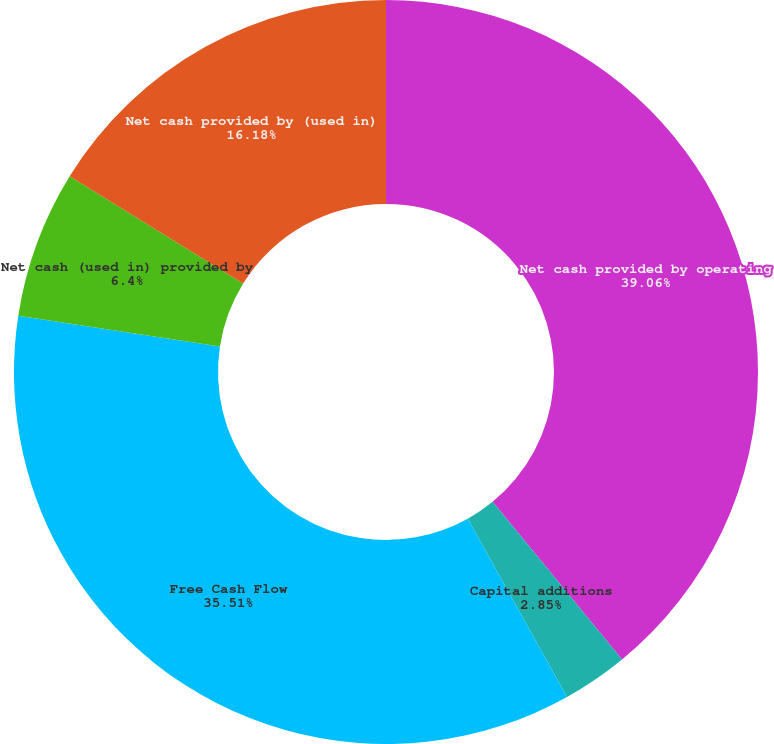Convert chart. <chart><loc_0><loc_0><loc_500><loc_500><pie_chart><fcel>Net cash provided by operating<fcel>Capital additions<fcel>Free Cash Flow<fcel>Net cash (used in) provided by<fcel>Net cash provided by (used in)<nl><fcel>39.06%<fcel>2.85%<fcel>35.51%<fcel>6.4%<fcel>16.18%<nl></chart> 